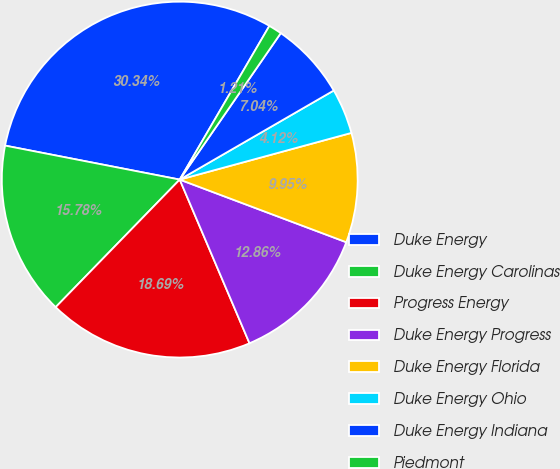<chart> <loc_0><loc_0><loc_500><loc_500><pie_chart><fcel>Duke Energy<fcel>Duke Energy Carolinas<fcel>Progress Energy<fcel>Duke Energy Progress<fcel>Duke Energy Florida<fcel>Duke Energy Ohio<fcel>Duke Energy Indiana<fcel>Piedmont<nl><fcel>30.34%<fcel>15.78%<fcel>18.69%<fcel>12.86%<fcel>9.95%<fcel>4.12%<fcel>7.04%<fcel>1.21%<nl></chart> 